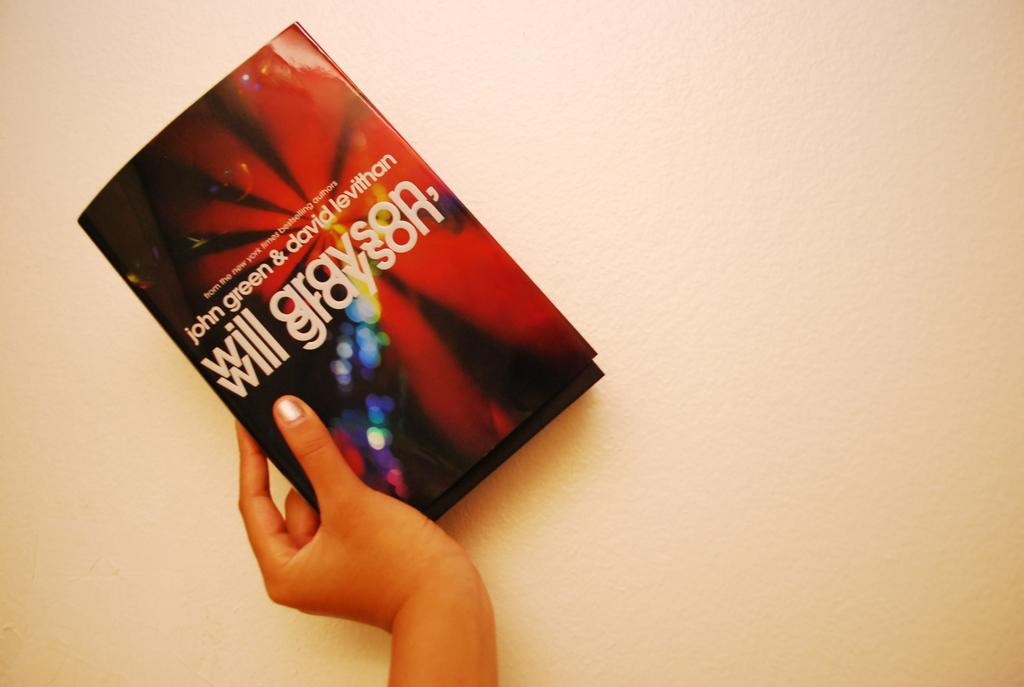<image>
Offer a succinct explanation of the picture presented. A hand holding the book Will Grayson written by John green and David Levithan. 